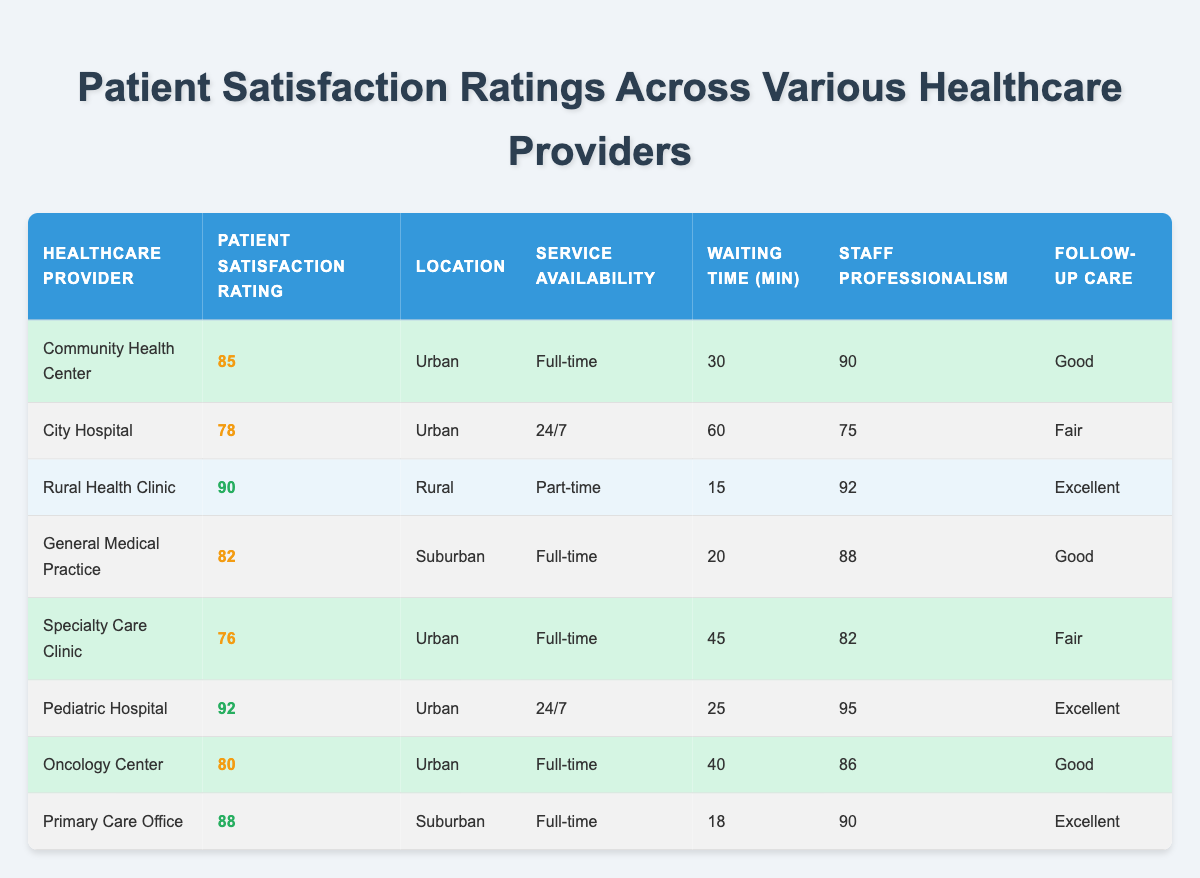What is the patient satisfaction rating for Pediatric Hospital? The table shows that the Pediatric Hospital has a patient satisfaction rating of 92.
Answer: 92 Which healthcare provider has the highest patient satisfaction rating? By comparing the patient satisfaction ratings listed in the table, Rural Health Clinic has the highest rating at 90.
Answer: Rural Health Clinic What is the average waiting time across all healthcare providers? To find the average waiting time, sum the waiting times: (30 + 60 + 15 + 20 + 45 + 25 + 40 + 18) = 253. There are 8 providers, so the average waiting time is 253/8 = 31.625, which can be approximated to 32 minutes.
Answer: 32 Is the service availability for Specialty Care Clinic full-time? Referring to the table, it clearly shows that the Specialty Care Clinic has full-time service availability.
Answer: Yes How much more staff professionalism does Pediatric Hospital have compared to City Hospital? Pediatric Hospital has a staff professionalism rating of 95, while City Hospital has a rating of 75. The difference is 95 - 75 = 20.
Answer: 20 What percentage of healthcare providers offer excellent follow-up care? There are 3 providers with excellent follow-up care (Rural Health Clinic, Pediatric Hospital, and Primary Care Office) out of 8 total providers. The percentage is (3/8) * 100 = 37.5%.
Answer: 37.5% List all urban healthcare providers that have a patient satisfaction rating above 80. From the table, Community Health Center (85), Pediatric Hospital (92), and Oncology Center (80) are the urban providers. Thus, the urban providers above 80 are Community Health Center and Pediatric Hospital.
Answer: Community Health Center, Pediatric Hospital What is the follow-up care quality of the Rural Health Clinic? According to the table, the Rural Health Clinic has been rated as having excellent follow-up care.
Answer: Excellent How many urban healthcare providers have a waiting time of less than 30 minutes? The table shows that only the Rural Health Clinic (15 minutes) qualifies for less than 30 minutes. Therefore, there is just one urban provider with a waiting time under 30 minutes.
Answer: 1 